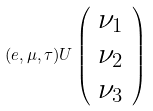<formula> <loc_0><loc_0><loc_500><loc_500>( e , \mu , \tau ) U \left ( \begin{array} { c } \nu _ { 1 } \\ \nu _ { 2 } \\ \nu _ { 3 } \end{array} \right )</formula> 